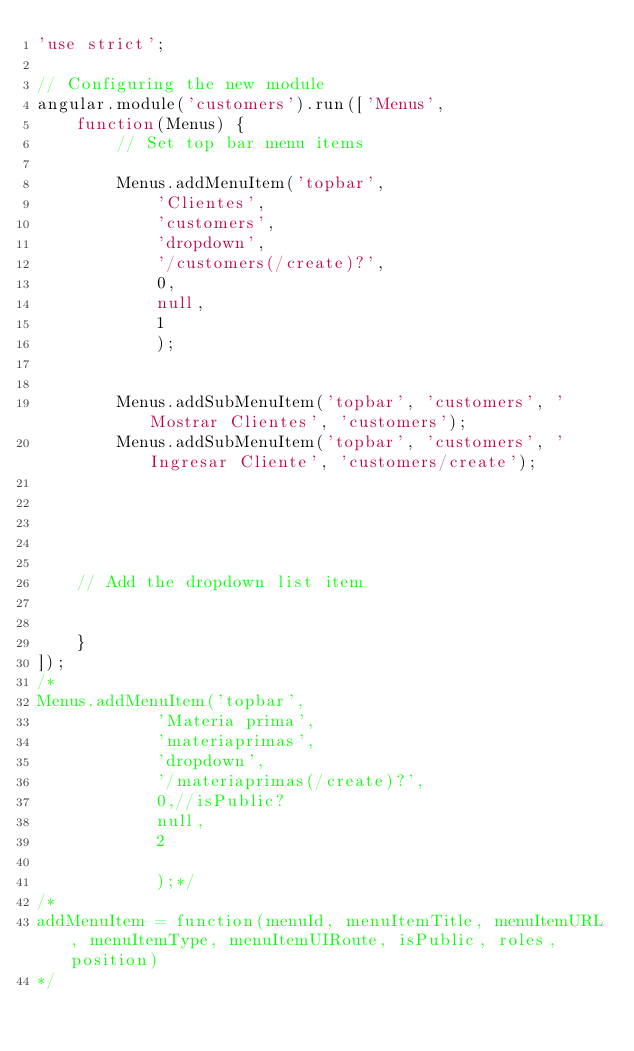<code> <loc_0><loc_0><loc_500><loc_500><_JavaScript_>'use strict';

// Configuring the new module
angular.module('customers').run(['Menus',
	function(Menus) {
		// Set top bar menu items
		
		Menus.addMenuItem('topbar', 
			'Clientes', 
			'customers', 
			'dropdown', 
			'/customers(/create)?',
			0,
			null,
			1
			);
			

		Menus.addSubMenuItem('topbar', 'customers', 'Mostrar Clientes', 'customers');
		Menus.addSubMenuItem('topbar', 'customers', 'Ingresar Cliente', 'customers/create');
	


	

    // Add the dropdown list item
   

	}
]);
/*
Menus.addMenuItem('topbar',
			'Materia prima', 
			'materiaprimas', 
			'dropdown', 
			'/materiaprimas(/create)?',
			0,//isPublic?
			null,
			2

			);*/
/*
addMenuItem = function(menuId, menuItemTitle, menuItemURL, menuItemType, menuItemUIRoute, isPublic, roles, position)
*/




</code> 